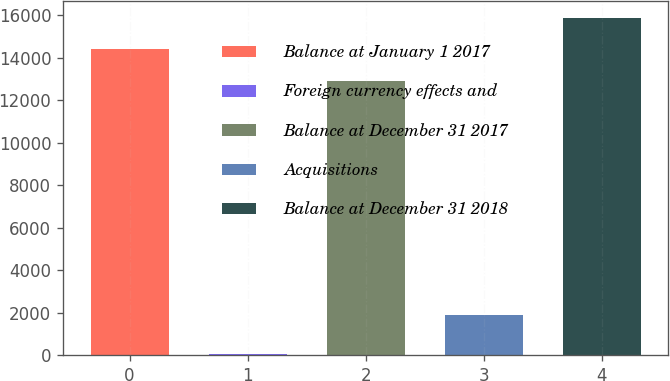Convert chart to OTSL. <chart><loc_0><loc_0><loc_500><loc_500><bar_chart><fcel>Balance at January 1 2017<fcel>Foreign currency effects and<fcel>Balance at December 31 2017<fcel>Acquisitions<fcel>Balance at December 31 2018<nl><fcel>14384.2<fcel>49<fcel>12910<fcel>1881<fcel>15858.4<nl></chart> 